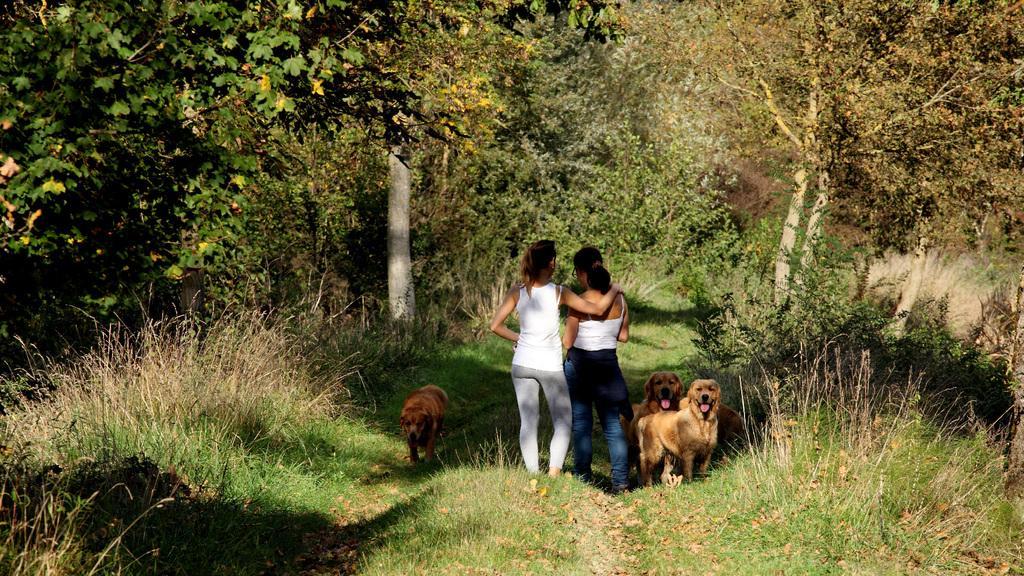Please provide a concise description of this image. In the picture we can see a grass surface with dried grass and two women are standing together and they are in a white top and beside them, we can see some dogs which are brown in color and some are cream in color and in the background we can see full of plants and trees. 